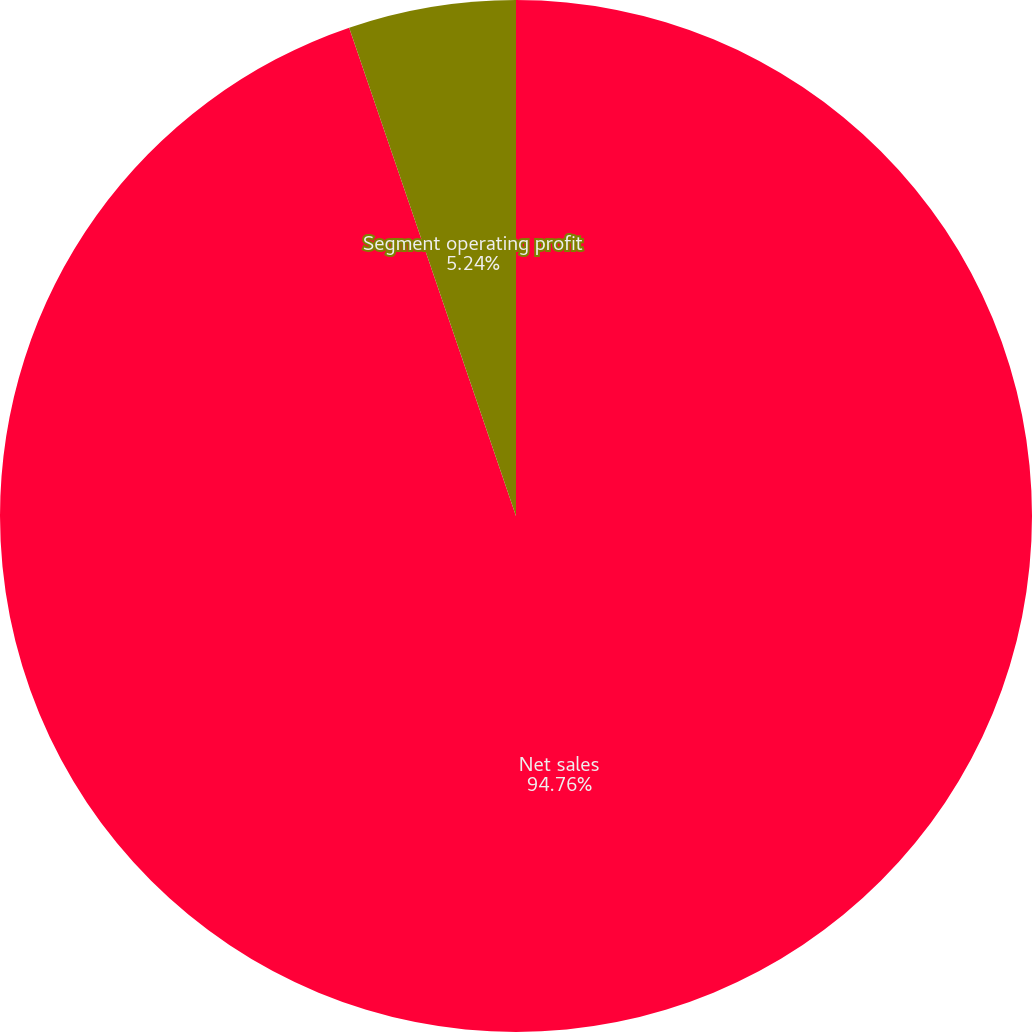Convert chart. <chart><loc_0><loc_0><loc_500><loc_500><pie_chart><fcel>Net sales<fcel>Segment operating profit<nl><fcel>94.76%<fcel>5.24%<nl></chart> 